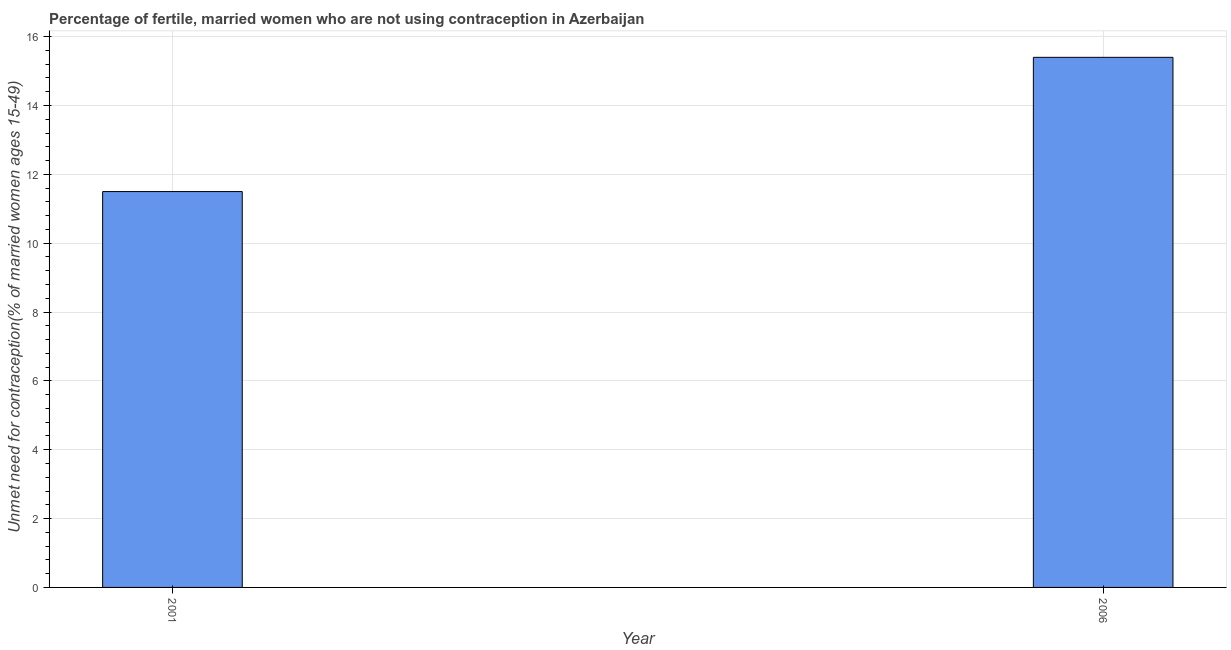What is the title of the graph?
Provide a succinct answer. Percentage of fertile, married women who are not using contraception in Azerbaijan. What is the label or title of the X-axis?
Provide a short and direct response. Year. What is the label or title of the Y-axis?
Provide a short and direct response.  Unmet need for contraception(% of married women ages 15-49). Across all years, what is the minimum number of married women who are not using contraception?
Provide a short and direct response. 11.5. In which year was the number of married women who are not using contraception maximum?
Your answer should be very brief. 2006. In which year was the number of married women who are not using contraception minimum?
Ensure brevity in your answer.  2001. What is the sum of the number of married women who are not using contraception?
Your answer should be compact. 26.9. What is the average number of married women who are not using contraception per year?
Your response must be concise. 13.45. What is the median number of married women who are not using contraception?
Your answer should be very brief. 13.45. What is the ratio of the number of married women who are not using contraception in 2001 to that in 2006?
Your response must be concise. 0.75. Is the number of married women who are not using contraception in 2001 less than that in 2006?
Your answer should be very brief. Yes. How many bars are there?
Offer a very short reply. 2. What is the difference between two consecutive major ticks on the Y-axis?
Your answer should be compact. 2. What is the difference between the  Unmet need for contraception(% of married women ages 15-49) in 2001 and 2006?
Provide a succinct answer. -3.9. What is the ratio of the  Unmet need for contraception(% of married women ages 15-49) in 2001 to that in 2006?
Provide a short and direct response. 0.75. 